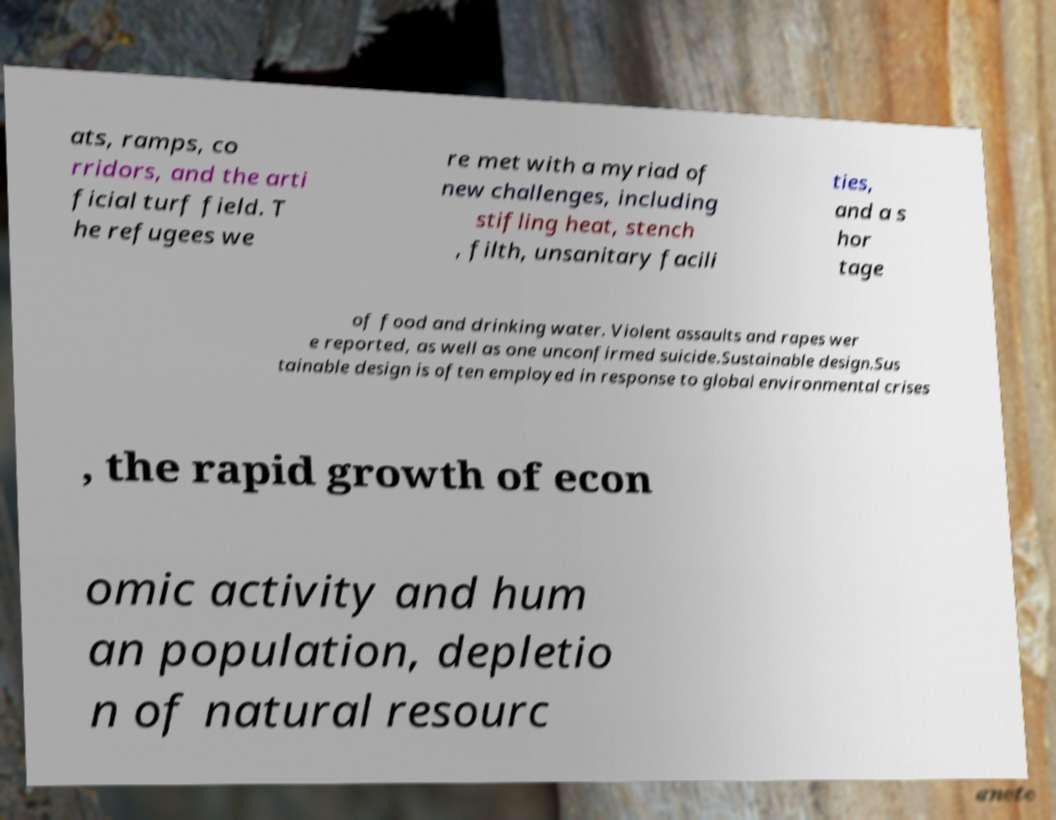Can you read and provide the text displayed in the image?This photo seems to have some interesting text. Can you extract and type it out for me? ats, ramps, co rridors, and the arti ficial turf field. T he refugees we re met with a myriad of new challenges, including stifling heat, stench , filth, unsanitary facili ties, and a s hor tage of food and drinking water. Violent assaults and rapes wer e reported, as well as one unconfirmed suicide.Sustainable design.Sus tainable design is often employed in response to global environmental crises , the rapid growth of econ omic activity and hum an population, depletio n of natural resourc 